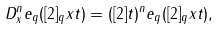Convert formula to latex. <formula><loc_0><loc_0><loc_500><loc_500>D ^ { n } _ { x } e _ { q } ( [ 2 ] _ { q } x t ) = ( [ 2 ] t ) ^ { n } e _ { q } ( [ 2 ] _ { q } x t ) ,</formula> 